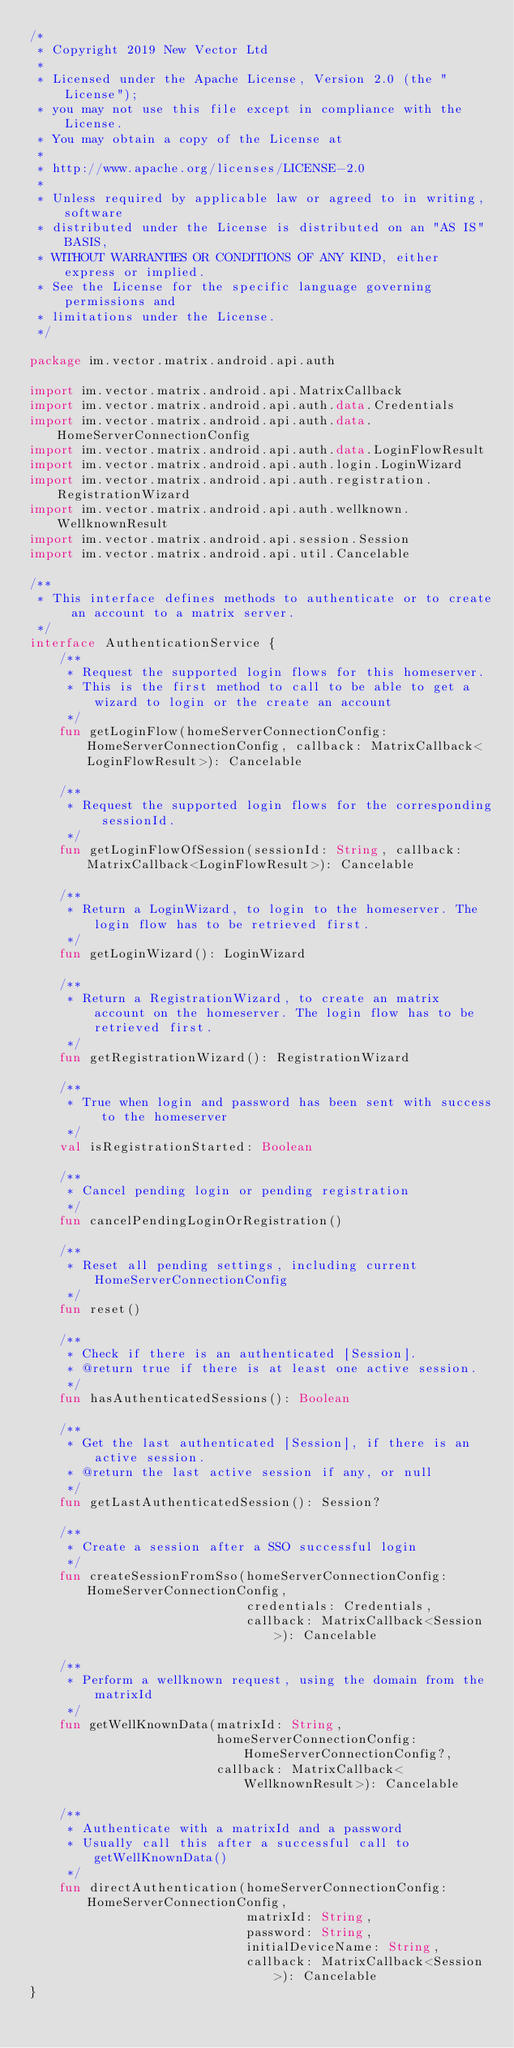Convert code to text. <code><loc_0><loc_0><loc_500><loc_500><_Kotlin_>/*
 * Copyright 2019 New Vector Ltd
 *
 * Licensed under the Apache License, Version 2.0 (the "License");
 * you may not use this file except in compliance with the License.
 * You may obtain a copy of the License at
 *
 * http://www.apache.org/licenses/LICENSE-2.0
 *
 * Unless required by applicable law or agreed to in writing, software
 * distributed under the License is distributed on an "AS IS" BASIS,
 * WITHOUT WARRANTIES OR CONDITIONS OF ANY KIND, either express or implied.
 * See the License for the specific language governing permissions and
 * limitations under the License.
 */

package im.vector.matrix.android.api.auth

import im.vector.matrix.android.api.MatrixCallback
import im.vector.matrix.android.api.auth.data.Credentials
import im.vector.matrix.android.api.auth.data.HomeServerConnectionConfig
import im.vector.matrix.android.api.auth.data.LoginFlowResult
import im.vector.matrix.android.api.auth.login.LoginWizard
import im.vector.matrix.android.api.auth.registration.RegistrationWizard
import im.vector.matrix.android.api.auth.wellknown.WellknownResult
import im.vector.matrix.android.api.session.Session
import im.vector.matrix.android.api.util.Cancelable

/**
 * This interface defines methods to authenticate or to create an account to a matrix server.
 */
interface AuthenticationService {
    /**
     * Request the supported login flows for this homeserver.
     * This is the first method to call to be able to get a wizard to login or the create an account
     */
    fun getLoginFlow(homeServerConnectionConfig: HomeServerConnectionConfig, callback: MatrixCallback<LoginFlowResult>): Cancelable

    /**
     * Request the supported login flows for the corresponding sessionId.
     */
    fun getLoginFlowOfSession(sessionId: String, callback: MatrixCallback<LoginFlowResult>): Cancelable

    /**
     * Return a LoginWizard, to login to the homeserver. The login flow has to be retrieved first.
     */
    fun getLoginWizard(): LoginWizard

    /**
     * Return a RegistrationWizard, to create an matrix account on the homeserver. The login flow has to be retrieved first.
     */
    fun getRegistrationWizard(): RegistrationWizard

    /**
     * True when login and password has been sent with success to the homeserver
     */
    val isRegistrationStarted: Boolean

    /**
     * Cancel pending login or pending registration
     */
    fun cancelPendingLoginOrRegistration()

    /**
     * Reset all pending settings, including current HomeServerConnectionConfig
     */
    fun reset()

    /**
     * Check if there is an authenticated [Session].
     * @return true if there is at least one active session.
     */
    fun hasAuthenticatedSessions(): Boolean

    /**
     * Get the last authenticated [Session], if there is an active session.
     * @return the last active session if any, or null
     */
    fun getLastAuthenticatedSession(): Session?

    /**
     * Create a session after a SSO successful login
     */
    fun createSessionFromSso(homeServerConnectionConfig: HomeServerConnectionConfig,
                             credentials: Credentials,
                             callback: MatrixCallback<Session>): Cancelable

    /**
     * Perform a wellknown request, using the domain from the matrixId
     */
    fun getWellKnownData(matrixId: String,
                         homeServerConnectionConfig: HomeServerConnectionConfig?,
                         callback: MatrixCallback<WellknownResult>): Cancelable

    /**
     * Authenticate with a matrixId and a password
     * Usually call this after a successful call to getWellKnownData()
     */
    fun directAuthentication(homeServerConnectionConfig: HomeServerConnectionConfig,
                             matrixId: String,
                             password: String,
                             initialDeviceName: String,
                             callback: MatrixCallback<Session>): Cancelable
}
</code> 